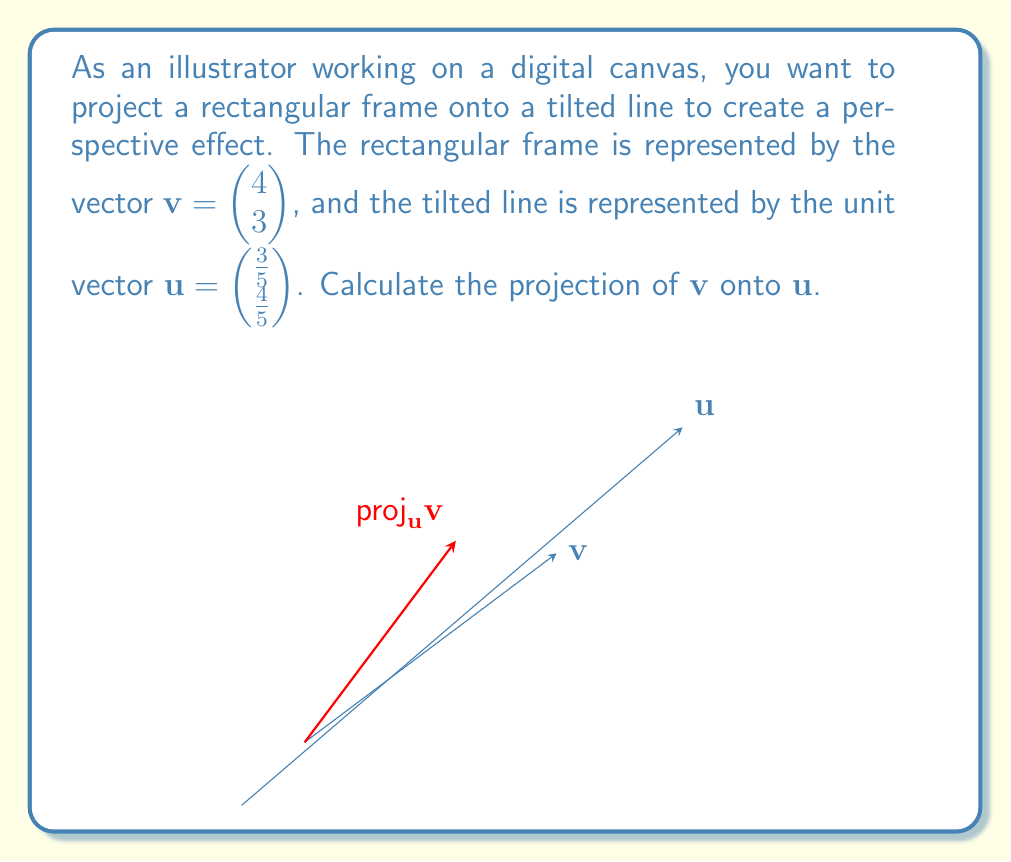Give your solution to this math problem. To calculate the projection of $\mathbf{v}$ onto $\mathbf{u}$, we use the formula:

$$\text{proj}_\mathbf{u}\mathbf{v} = \frac{\mathbf{v} \cdot \mathbf{u}}{\|\mathbf{u}\|^2} \mathbf{u}$$

Given:
$\mathbf{v} = \begin{pmatrix} 4 \\ 3 \end{pmatrix}$ and $\mathbf{u} = \begin{pmatrix} \frac{3}{5} \\ \frac{4}{5} \end{pmatrix}$

Step 1: Calculate the dot product $\mathbf{v} \cdot \mathbf{u}$
$$\mathbf{v} \cdot \mathbf{u} = 4 \cdot \frac{3}{5} + 3 \cdot \frac{4}{5} = \frac{12}{5} + \frac{12}{5} = \frac{24}{5}$$

Step 2: Calculate $\|\mathbf{u}\|^2$
$$\|\mathbf{u}\|^2 = (\frac{3}{5})^2 + (\frac{4}{5})^2 = \frac{9}{25} + \frac{16}{25} = 1$$

Step 3: Calculate the scalar projection
$$\frac{\mathbf{v} \cdot \mathbf{u}}{\|\mathbf{u}\|^2} = \frac{24/5}{1} = \frac{24}{5}$$

Step 4: Multiply the scalar projection by $\mathbf{u}$ to get the vector projection
$$\text{proj}_\mathbf{u}\mathbf{v} = \frac{24}{5} \begin{pmatrix} \frac{3}{5} \\ \frac{4}{5} \end{pmatrix} = \begin{pmatrix} \frac{72}{25} \\ \frac{96}{25} \end{pmatrix}$$
Answer: The projection of $\mathbf{v}$ onto $\mathbf{u}$ is $\begin{pmatrix} \frac{72}{25} \\ \frac{96}{25} \end{pmatrix}$ or $\begin{pmatrix} 2.88 \\ 3.84 \end{pmatrix}$ (rounded to two decimal places). 